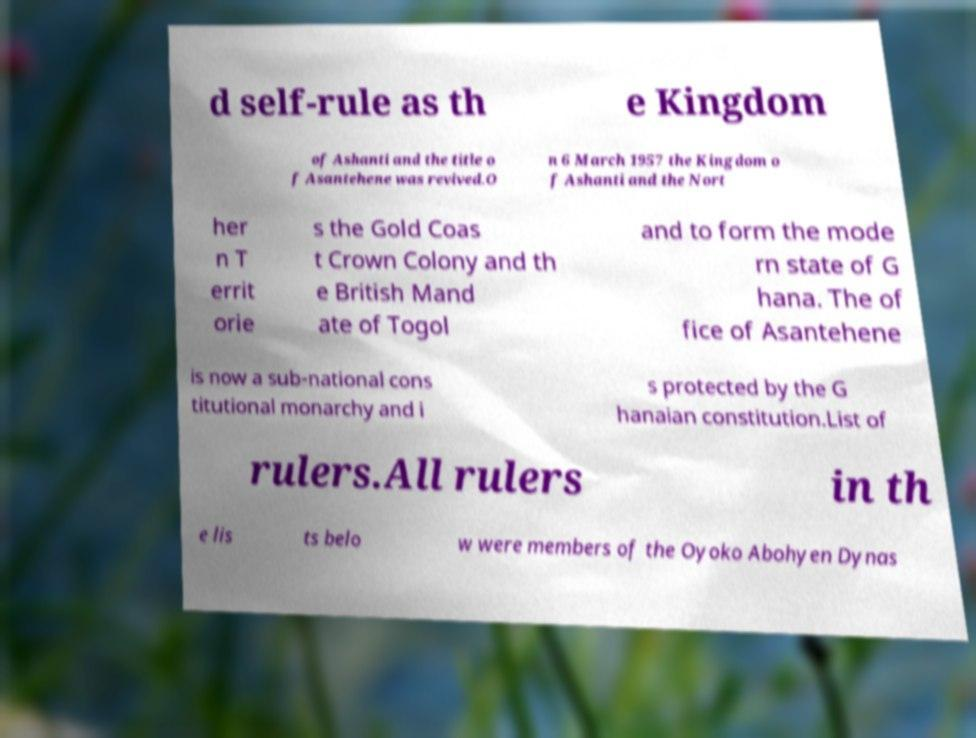For documentation purposes, I need the text within this image transcribed. Could you provide that? d self-rule as th e Kingdom of Ashanti and the title o f Asantehene was revived.O n 6 March 1957 the Kingdom o f Ashanti and the Nort her n T errit orie s the Gold Coas t Crown Colony and th e British Mand ate of Togol and to form the mode rn state of G hana. The of fice of Asantehene is now a sub-national cons titutional monarchy and i s protected by the G hanaian constitution.List of rulers.All rulers in th e lis ts belo w were members of the Oyoko Abohyen Dynas 